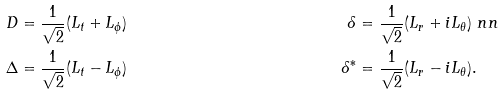<formula> <loc_0><loc_0><loc_500><loc_500>D & = \frac { 1 } { \sqrt { 2 } } ( L _ { t } + L _ { \phi } ) & \delta & = \frac { 1 } { \sqrt { 2 } } ( L _ { r } + i L _ { \theta } ) \ n n \\ \Delta & = \frac { 1 } { \sqrt { 2 } } ( L _ { t } - L _ { \phi } ) & \delta ^ { \ast } & = \frac { 1 } { \sqrt { 2 } } ( L _ { r } - i L _ { \theta } ) .</formula> 